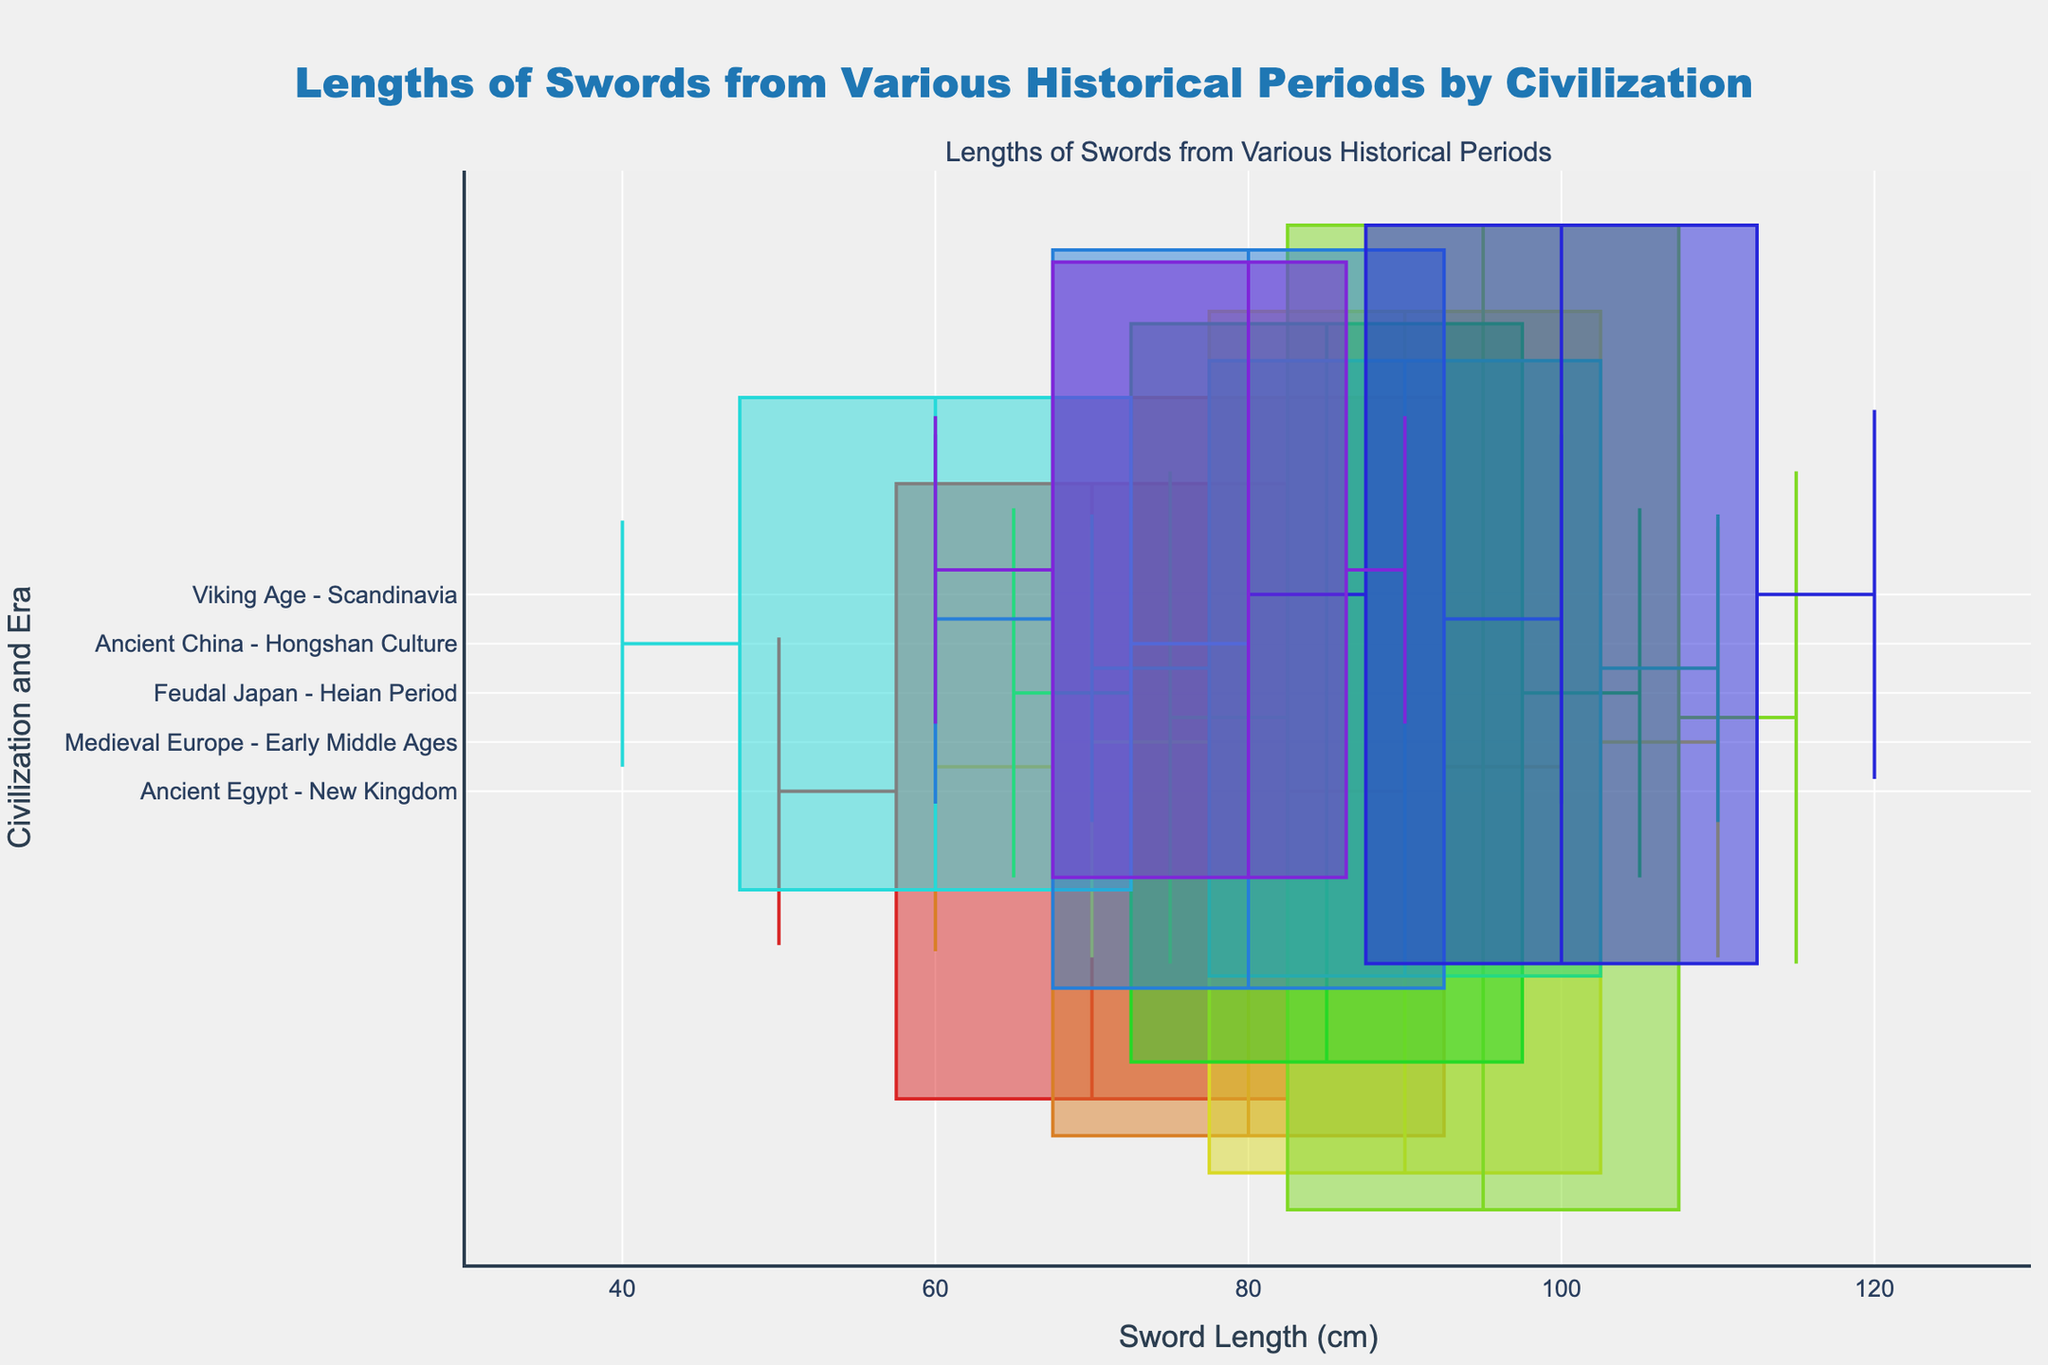what is the title of the figure? The title is displayed at the top of the figure, indicating the main topic being visualized. The title of the figure is "Lengths of Swords from Various Historical Periods by Civilization."
Answer: Lengths of Swords from Various Historical Periods by Civilization Which civilization has the longest median sword length? To find the civilization with the longest median sword length, look at the positions of the median lines on the x-axis for each box plot. The median line representing the sword length of 100 cm in Scandinavia during the Viking Age is the longest among all the civilizations.
Answer: Viking Age - Scandinavia How do the sword lengths of Medieval Europe in the Early Middle Ages and the High Middle Ages compare? Compare the positions of the box plots for these two periods horizontally. The swords from the High Middle Ages have a higher median, quartiles, and maximum length compared to those from the Early Middle Ages. Specifically, the median lengths are 95 cm and 90 cm, respectively, and the maximum lengths are 115 cm and 110 cm.
Answer: High Middle Ages swords are longer What is the interquartile range of sword lengths during the Heian Period in Feudal Japan? The interquartile range (IQR) is calculated as the difference between the third quartile (Q3) and the first quartile (Q1). For Heian Period swords, Q3 is 95 cm, and Q1 is 75 cm. Therefore, the IQR is 95 - 75 = 20 cm.
Answer: 20 cm Which historical era in Feudal Japan has a larger sample size? To determine the era with the larger sample size, compare the widths of the box plots for the Heian Period and the Edo Period. The Heian Period has wider boxes, suggesting it has a larger sample size (6 samples compared to 5 in the Edo Period).
Answer: Heian Period What is the range of sword lengths in ancient Greece during the Classical Period? The range is calculated as the difference between the maximum and minimum values. For Classical Period Greece swords, the maximum length is 90 cm, and the minimum length is 60 cm. So, the range is 90 - 60 = 30 cm.
Answer: 30 cm Which civilization has the smallest range of sword lengths? To find the smallest range, look for the box plot with the shortest span from the minimum to the maximum value. The Hongshan Culture in Ancient China has the smallest range, with sword lengths ranging from 40 cm to 80 cm, resulting in a range of 40 cm.
Answer: Ancient China - Hongshan Culture How does the median sword length of Ancient Rome during the Imperial Period compare to that of Ancient Greece during the Classical Period? Compare the median lines of the two box plots. The median length of swords in Ancient Rome is 80 cm, while in Ancient Greece, it's also 80 cm. Therefore, both have the same median sword length.
Answer: Equal Which era has a minimum sword length similar to the median sword length of Ancient Egypt during the New Kingdom? The median sword length of Ancient Egypt during the New Kingdom is 70 cm. Identify the era with a minimum sword length close to 70 cm. The Edo Period in Feudal Japan has a minimum sword length of 70 cm, similar to the median length of Ancient Egypt.
Answer: Edo Period - Feudal Japan 